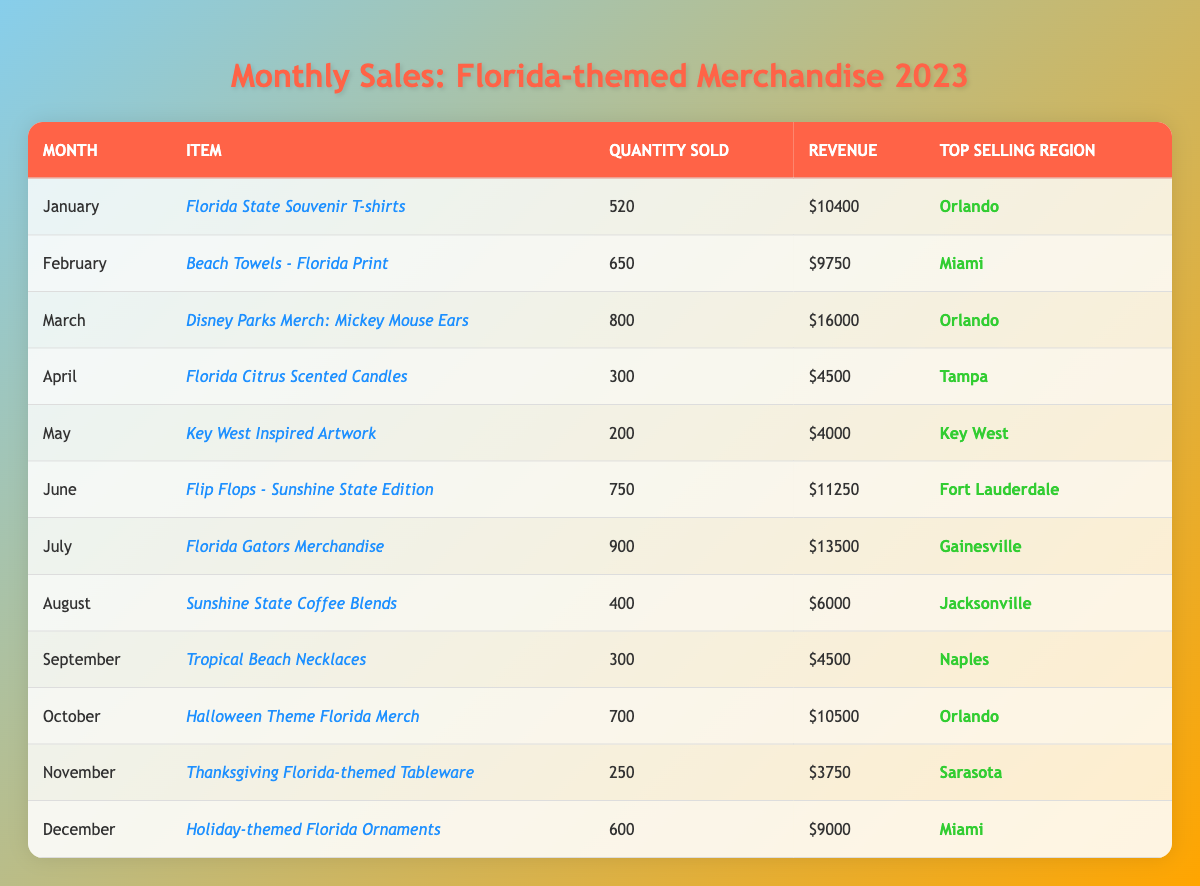What was the best-selling item in March? In March, the best-selling item was "Disney Parks Merch: Mickey Mouse Ears," with 800 units sold.
Answer: Disney Parks Merch: Mickey Mouse Ears How much revenue was generated from sales of Key West Inspired Artwork? The revenue from sales of "Key West Inspired Artwork" in May was $4,000.
Answer: $4,000 Which month had the highest revenue, and how much was it? The month of March had the highest revenue, generating $16,000 from sales of Mickey Mouse Ears.
Answer: March, $16,000 How many more units of Florida Gators Merchandise were sold compared to Tropical Beach Necklaces? Florida Gators Merchandise sold 900 units, while Tropical Beach Necklaces sold 300 units. The difference is 900 - 300 = 600 units.
Answer: 600 units Which region had the highest sales of merchandise, and in which month? The Orlando region had the highest sales, with the best-selling items in January (T-shirts) and March (Mickey Mouse Ears), generating $10,400 and $16,000 respectively.
Answer: Orlando What was the total quantity of merchandise sold from May to August? From May (200 units) to August (400 units), the total sold is 200 + 250 + 750 + 900 = 2600 units.
Answer: 2600 units Is it true that more units of flip-flops were sold than Florida Citrus Scented Candles? Yes, 750 units of Flip Flops were sold compared to 300 units of Citrus Candles, so the statement is true.
Answer: True What was the average revenue generated per month for the months of November and December? November generated $3,750 and December generated $9,000. The average revenue is calculated as (3750 + 9000) / 2 = $6,375.
Answer: $6,375 Which item ranked second in sales for the month of July? The highest selling item in July was Florida Gators Merchandise at 900 units; there is no second item listed. Therefore, we cannot identify a second item.
Answer: N/A In which month did the revenue for Halloween Theme Florida Merch surpass $10,000? In October, the revenue from Halloween Theme Florida Merch reached $10,500, which is the only instance where it surpassed $10,000.
Answer: October 